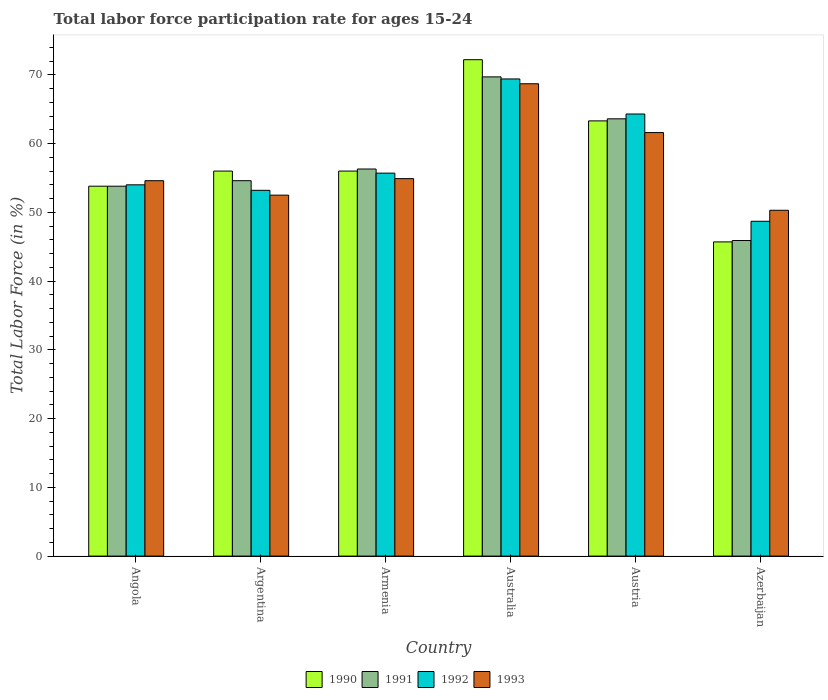How many different coloured bars are there?
Give a very brief answer. 4. How many groups of bars are there?
Your answer should be compact. 6. Are the number of bars per tick equal to the number of legend labels?
Your answer should be very brief. Yes. What is the label of the 2nd group of bars from the left?
Offer a terse response. Argentina. What is the labor force participation rate in 1992 in Argentina?
Make the answer very short. 53.2. Across all countries, what is the maximum labor force participation rate in 1992?
Ensure brevity in your answer.  69.4. Across all countries, what is the minimum labor force participation rate in 1992?
Your answer should be compact. 48.7. In which country was the labor force participation rate in 1992 maximum?
Offer a terse response. Australia. In which country was the labor force participation rate in 1990 minimum?
Offer a terse response. Azerbaijan. What is the total labor force participation rate in 1991 in the graph?
Your answer should be very brief. 343.9. What is the difference between the labor force participation rate in 1991 in Angola and that in Australia?
Keep it short and to the point. -15.9. What is the difference between the labor force participation rate in 1993 in Austria and the labor force participation rate in 1990 in Australia?
Keep it short and to the point. -10.6. What is the average labor force participation rate in 1993 per country?
Provide a short and direct response. 57.1. What is the difference between the labor force participation rate of/in 1992 and labor force participation rate of/in 1993 in Argentina?
Offer a terse response. 0.7. What is the ratio of the labor force participation rate in 1992 in Argentina to that in Austria?
Make the answer very short. 0.83. Is the labor force participation rate in 1992 in Australia less than that in Azerbaijan?
Make the answer very short. No. Is the difference between the labor force participation rate in 1992 in Argentina and Austria greater than the difference between the labor force participation rate in 1993 in Argentina and Austria?
Provide a succinct answer. No. What is the difference between the highest and the second highest labor force participation rate in 1990?
Give a very brief answer. 16.2. What is the difference between the highest and the lowest labor force participation rate in 1990?
Offer a very short reply. 26.5. In how many countries, is the labor force participation rate in 1990 greater than the average labor force participation rate in 1990 taken over all countries?
Provide a short and direct response. 2. Is the sum of the labor force participation rate in 1993 in Argentina and Armenia greater than the maximum labor force participation rate in 1991 across all countries?
Provide a succinct answer. Yes. What does the 4th bar from the right in Austria represents?
Offer a terse response. 1990. Is it the case that in every country, the sum of the labor force participation rate in 1992 and labor force participation rate in 1990 is greater than the labor force participation rate in 1991?
Provide a succinct answer. Yes. How many bars are there?
Your answer should be compact. 24. Are all the bars in the graph horizontal?
Your response must be concise. No. What is the difference between two consecutive major ticks on the Y-axis?
Provide a short and direct response. 10. Are the values on the major ticks of Y-axis written in scientific E-notation?
Offer a terse response. No. Does the graph contain any zero values?
Your response must be concise. No. Does the graph contain grids?
Offer a very short reply. No. Where does the legend appear in the graph?
Make the answer very short. Bottom center. How many legend labels are there?
Your answer should be compact. 4. How are the legend labels stacked?
Your answer should be compact. Horizontal. What is the title of the graph?
Ensure brevity in your answer.  Total labor force participation rate for ages 15-24. Does "1978" appear as one of the legend labels in the graph?
Make the answer very short. No. What is the Total Labor Force (in %) in 1990 in Angola?
Provide a short and direct response. 53.8. What is the Total Labor Force (in %) of 1991 in Angola?
Offer a terse response. 53.8. What is the Total Labor Force (in %) of 1992 in Angola?
Offer a terse response. 54. What is the Total Labor Force (in %) of 1993 in Angola?
Keep it short and to the point. 54.6. What is the Total Labor Force (in %) in 1990 in Argentina?
Make the answer very short. 56. What is the Total Labor Force (in %) of 1991 in Argentina?
Offer a terse response. 54.6. What is the Total Labor Force (in %) in 1992 in Argentina?
Offer a very short reply. 53.2. What is the Total Labor Force (in %) in 1993 in Argentina?
Provide a succinct answer. 52.5. What is the Total Labor Force (in %) of 1991 in Armenia?
Make the answer very short. 56.3. What is the Total Labor Force (in %) of 1992 in Armenia?
Give a very brief answer. 55.7. What is the Total Labor Force (in %) in 1993 in Armenia?
Your answer should be very brief. 54.9. What is the Total Labor Force (in %) in 1990 in Australia?
Make the answer very short. 72.2. What is the Total Labor Force (in %) of 1991 in Australia?
Offer a terse response. 69.7. What is the Total Labor Force (in %) in 1992 in Australia?
Provide a succinct answer. 69.4. What is the Total Labor Force (in %) of 1993 in Australia?
Keep it short and to the point. 68.7. What is the Total Labor Force (in %) in 1990 in Austria?
Provide a succinct answer. 63.3. What is the Total Labor Force (in %) in 1991 in Austria?
Provide a succinct answer. 63.6. What is the Total Labor Force (in %) of 1992 in Austria?
Give a very brief answer. 64.3. What is the Total Labor Force (in %) of 1993 in Austria?
Offer a very short reply. 61.6. What is the Total Labor Force (in %) of 1990 in Azerbaijan?
Provide a short and direct response. 45.7. What is the Total Labor Force (in %) in 1991 in Azerbaijan?
Keep it short and to the point. 45.9. What is the Total Labor Force (in %) of 1992 in Azerbaijan?
Offer a terse response. 48.7. What is the Total Labor Force (in %) in 1993 in Azerbaijan?
Give a very brief answer. 50.3. Across all countries, what is the maximum Total Labor Force (in %) in 1990?
Provide a succinct answer. 72.2. Across all countries, what is the maximum Total Labor Force (in %) of 1991?
Offer a terse response. 69.7. Across all countries, what is the maximum Total Labor Force (in %) of 1992?
Your answer should be very brief. 69.4. Across all countries, what is the maximum Total Labor Force (in %) in 1993?
Make the answer very short. 68.7. Across all countries, what is the minimum Total Labor Force (in %) of 1990?
Provide a short and direct response. 45.7. Across all countries, what is the minimum Total Labor Force (in %) in 1991?
Provide a succinct answer. 45.9. Across all countries, what is the minimum Total Labor Force (in %) in 1992?
Keep it short and to the point. 48.7. Across all countries, what is the minimum Total Labor Force (in %) in 1993?
Offer a terse response. 50.3. What is the total Total Labor Force (in %) of 1990 in the graph?
Offer a terse response. 347. What is the total Total Labor Force (in %) of 1991 in the graph?
Offer a very short reply. 343.9. What is the total Total Labor Force (in %) in 1992 in the graph?
Your answer should be compact. 345.3. What is the total Total Labor Force (in %) in 1993 in the graph?
Give a very brief answer. 342.6. What is the difference between the Total Labor Force (in %) in 1990 in Angola and that in Argentina?
Provide a short and direct response. -2.2. What is the difference between the Total Labor Force (in %) of 1991 in Angola and that in Argentina?
Your answer should be compact. -0.8. What is the difference between the Total Labor Force (in %) of 1992 in Angola and that in Argentina?
Your answer should be compact. 0.8. What is the difference between the Total Labor Force (in %) of 1990 in Angola and that in Australia?
Keep it short and to the point. -18.4. What is the difference between the Total Labor Force (in %) of 1991 in Angola and that in Australia?
Provide a succinct answer. -15.9. What is the difference between the Total Labor Force (in %) in 1992 in Angola and that in Australia?
Keep it short and to the point. -15.4. What is the difference between the Total Labor Force (in %) in 1993 in Angola and that in Australia?
Your answer should be very brief. -14.1. What is the difference between the Total Labor Force (in %) in 1991 in Angola and that in Austria?
Ensure brevity in your answer.  -9.8. What is the difference between the Total Labor Force (in %) of 1990 in Angola and that in Azerbaijan?
Keep it short and to the point. 8.1. What is the difference between the Total Labor Force (in %) of 1992 in Angola and that in Azerbaijan?
Keep it short and to the point. 5.3. What is the difference between the Total Labor Force (in %) in 1993 in Angola and that in Azerbaijan?
Your response must be concise. 4.3. What is the difference between the Total Labor Force (in %) in 1991 in Argentina and that in Armenia?
Your answer should be compact. -1.7. What is the difference between the Total Labor Force (in %) in 1990 in Argentina and that in Australia?
Offer a very short reply. -16.2. What is the difference between the Total Labor Force (in %) of 1991 in Argentina and that in Australia?
Give a very brief answer. -15.1. What is the difference between the Total Labor Force (in %) of 1992 in Argentina and that in Australia?
Keep it short and to the point. -16.2. What is the difference between the Total Labor Force (in %) of 1993 in Argentina and that in Australia?
Ensure brevity in your answer.  -16.2. What is the difference between the Total Labor Force (in %) of 1990 in Argentina and that in Austria?
Your answer should be compact. -7.3. What is the difference between the Total Labor Force (in %) of 1992 in Argentina and that in Austria?
Ensure brevity in your answer.  -11.1. What is the difference between the Total Labor Force (in %) in 1991 in Argentina and that in Azerbaijan?
Keep it short and to the point. 8.7. What is the difference between the Total Labor Force (in %) in 1993 in Argentina and that in Azerbaijan?
Offer a very short reply. 2.2. What is the difference between the Total Labor Force (in %) in 1990 in Armenia and that in Australia?
Give a very brief answer. -16.2. What is the difference between the Total Labor Force (in %) in 1991 in Armenia and that in Australia?
Your response must be concise. -13.4. What is the difference between the Total Labor Force (in %) of 1992 in Armenia and that in Australia?
Provide a short and direct response. -13.7. What is the difference between the Total Labor Force (in %) of 1993 in Armenia and that in Australia?
Offer a very short reply. -13.8. What is the difference between the Total Labor Force (in %) of 1990 in Armenia and that in Austria?
Keep it short and to the point. -7.3. What is the difference between the Total Labor Force (in %) of 1990 in Armenia and that in Azerbaijan?
Offer a terse response. 10.3. What is the difference between the Total Labor Force (in %) of 1992 in Armenia and that in Azerbaijan?
Give a very brief answer. 7. What is the difference between the Total Labor Force (in %) in 1993 in Armenia and that in Azerbaijan?
Provide a short and direct response. 4.6. What is the difference between the Total Labor Force (in %) of 1991 in Australia and that in Austria?
Keep it short and to the point. 6.1. What is the difference between the Total Labor Force (in %) of 1991 in Australia and that in Azerbaijan?
Offer a terse response. 23.8. What is the difference between the Total Labor Force (in %) of 1992 in Australia and that in Azerbaijan?
Your response must be concise. 20.7. What is the difference between the Total Labor Force (in %) in 1993 in Australia and that in Azerbaijan?
Keep it short and to the point. 18.4. What is the difference between the Total Labor Force (in %) in 1990 in Austria and that in Azerbaijan?
Offer a terse response. 17.6. What is the difference between the Total Labor Force (in %) in 1991 in Austria and that in Azerbaijan?
Keep it short and to the point. 17.7. What is the difference between the Total Labor Force (in %) of 1992 in Austria and that in Azerbaijan?
Offer a terse response. 15.6. What is the difference between the Total Labor Force (in %) of 1991 in Angola and the Total Labor Force (in %) of 1993 in Armenia?
Keep it short and to the point. -1.1. What is the difference between the Total Labor Force (in %) of 1992 in Angola and the Total Labor Force (in %) of 1993 in Armenia?
Your answer should be very brief. -0.9. What is the difference between the Total Labor Force (in %) of 1990 in Angola and the Total Labor Force (in %) of 1991 in Australia?
Keep it short and to the point. -15.9. What is the difference between the Total Labor Force (in %) in 1990 in Angola and the Total Labor Force (in %) in 1992 in Australia?
Your answer should be compact. -15.6. What is the difference between the Total Labor Force (in %) in 1990 in Angola and the Total Labor Force (in %) in 1993 in Australia?
Ensure brevity in your answer.  -14.9. What is the difference between the Total Labor Force (in %) of 1991 in Angola and the Total Labor Force (in %) of 1992 in Australia?
Make the answer very short. -15.6. What is the difference between the Total Labor Force (in %) in 1991 in Angola and the Total Labor Force (in %) in 1993 in Australia?
Provide a succinct answer. -14.9. What is the difference between the Total Labor Force (in %) in 1992 in Angola and the Total Labor Force (in %) in 1993 in Australia?
Make the answer very short. -14.7. What is the difference between the Total Labor Force (in %) of 1990 in Angola and the Total Labor Force (in %) of 1991 in Austria?
Your response must be concise. -9.8. What is the difference between the Total Labor Force (in %) of 1990 in Angola and the Total Labor Force (in %) of 1992 in Austria?
Provide a succinct answer. -10.5. What is the difference between the Total Labor Force (in %) in 1990 in Angola and the Total Labor Force (in %) in 1993 in Austria?
Ensure brevity in your answer.  -7.8. What is the difference between the Total Labor Force (in %) of 1990 in Angola and the Total Labor Force (in %) of 1992 in Azerbaijan?
Your answer should be compact. 5.1. What is the difference between the Total Labor Force (in %) of 1990 in Angola and the Total Labor Force (in %) of 1993 in Azerbaijan?
Offer a terse response. 3.5. What is the difference between the Total Labor Force (in %) in 1991 in Angola and the Total Labor Force (in %) in 1992 in Azerbaijan?
Ensure brevity in your answer.  5.1. What is the difference between the Total Labor Force (in %) of 1992 in Angola and the Total Labor Force (in %) of 1993 in Azerbaijan?
Give a very brief answer. 3.7. What is the difference between the Total Labor Force (in %) in 1990 in Argentina and the Total Labor Force (in %) in 1991 in Armenia?
Make the answer very short. -0.3. What is the difference between the Total Labor Force (in %) of 1990 in Argentina and the Total Labor Force (in %) of 1993 in Armenia?
Ensure brevity in your answer.  1.1. What is the difference between the Total Labor Force (in %) of 1991 in Argentina and the Total Labor Force (in %) of 1992 in Armenia?
Your response must be concise. -1.1. What is the difference between the Total Labor Force (in %) of 1992 in Argentina and the Total Labor Force (in %) of 1993 in Armenia?
Give a very brief answer. -1.7. What is the difference between the Total Labor Force (in %) in 1990 in Argentina and the Total Labor Force (in %) in 1991 in Australia?
Make the answer very short. -13.7. What is the difference between the Total Labor Force (in %) in 1991 in Argentina and the Total Labor Force (in %) in 1992 in Australia?
Provide a succinct answer. -14.8. What is the difference between the Total Labor Force (in %) in 1991 in Argentina and the Total Labor Force (in %) in 1993 in Australia?
Make the answer very short. -14.1. What is the difference between the Total Labor Force (in %) of 1992 in Argentina and the Total Labor Force (in %) of 1993 in Australia?
Offer a terse response. -15.5. What is the difference between the Total Labor Force (in %) of 1990 in Argentina and the Total Labor Force (in %) of 1991 in Austria?
Provide a short and direct response. -7.6. What is the difference between the Total Labor Force (in %) in 1991 in Argentina and the Total Labor Force (in %) in 1992 in Austria?
Offer a terse response. -9.7. What is the difference between the Total Labor Force (in %) in 1992 in Argentina and the Total Labor Force (in %) in 1993 in Austria?
Keep it short and to the point. -8.4. What is the difference between the Total Labor Force (in %) in 1990 in Argentina and the Total Labor Force (in %) in 1991 in Azerbaijan?
Keep it short and to the point. 10.1. What is the difference between the Total Labor Force (in %) of 1991 in Argentina and the Total Labor Force (in %) of 1992 in Azerbaijan?
Provide a short and direct response. 5.9. What is the difference between the Total Labor Force (in %) of 1990 in Armenia and the Total Labor Force (in %) of 1991 in Australia?
Ensure brevity in your answer.  -13.7. What is the difference between the Total Labor Force (in %) in 1990 in Armenia and the Total Labor Force (in %) in 1992 in Australia?
Give a very brief answer. -13.4. What is the difference between the Total Labor Force (in %) of 1990 in Armenia and the Total Labor Force (in %) of 1993 in Australia?
Provide a short and direct response. -12.7. What is the difference between the Total Labor Force (in %) of 1991 in Armenia and the Total Labor Force (in %) of 1992 in Australia?
Keep it short and to the point. -13.1. What is the difference between the Total Labor Force (in %) in 1992 in Armenia and the Total Labor Force (in %) in 1993 in Australia?
Offer a very short reply. -13. What is the difference between the Total Labor Force (in %) of 1990 in Armenia and the Total Labor Force (in %) of 1991 in Austria?
Make the answer very short. -7.6. What is the difference between the Total Labor Force (in %) in 1990 in Armenia and the Total Labor Force (in %) in 1992 in Austria?
Your answer should be very brief. -8.3. What is the difference between the Total Labor Force (in %) of 1990 in Armenia and the Total Labor Force (in %) of 1993 in Austria?
Give a very brief answer. -5.6. What is the difference between the Total Labor Force (in %) of 1991 in Armenia and the Total Labor Force (in %) of 1992 in Austria?
Offer a very short reply. -8. What is the difference between the Total Labor Force (in %) of 1991 in Armenia and the Total Labor Force (in %) of 1993 in Austria?
Offer a terse response. -5.3. What is the difference between the Total Labor Force (in %) in 1990 in Armenia and the Total Labor Force (in %) in 1991 in Azerbaijan?
Ensure brevity in your answer.  10.1. What is the difference between the Total Labor Force (in %) of 1991 in Armenia and the Total Labor Force (in %) of 1992 in Azerbaijan?
Make the answer very short. 7.6. What is the difference between the Total Labor Force (in %) in 1990 in Australia and the Total Labor Force (in %) in 1991 in Austria?
Your answer should be very brief. 8.6. What is the difference between the Total Labor Force (in %) of 1991 in Australia and the Total Labor Force (in %) of 1993 in Austria?
Make the answer very short. 8.1. What is the difference between the Total Labor Force (in %) in 1990 in Australia and the Total Labor Force (in %) in 1991 in Azerbaijan?
Provide a short and direct response. 26.3. What is the difference between the Total Labor Force (in %) in 1990 in Australia and the Total Labor Force (in %) in 1992 in Azerbaijan?
Your answer should be very brief. 23.5. What is the difference between the Total Labor Force (in %) in 1990 in Australia and the Total Labor Force (in %) in 1993 in Azerbaijan?
Offer a terse response. 21.9. What is the difference between the Total Labor Force (in %) in 1991 in Australia and the Total Labor Force (in %) in 1992 in Azerbaijan?
Give a very brief answer. 21. What is the difference between the Total Labor Force (in %) of 1990 in Austria and the Total Labor Force (in %) of 1991 in Azerbaijan?
Ensure brevity in your answer.  17.4. What is the difference between the Total Labor Force (in %) of 1990 in Austria and the Total Labor Force (in %) of 1992 in Azerbaijan?
Keep it short and to the point. 14.6. What is the difference between the Total Labor Force (in %) in 1990 in Austria and the Total Labor Force (in %) in 1993 in Azerbaijan?
Offer a very short reply. 13. What is the difference between the Total Labor Force (in %) in 1991 in Austria and the Total Labor Force (in %) in 1993 in Azerbaijan?
Ensure brevity in your answer.  13.3. What is the average Total Labor Force (in %) of 1990 per country?
Make the answer very short. 57.83. What is the average Total Labor Force (in %) of 1991 per country?
Provide a succinct answer. 57.32. What is the average Total Labor Force (in %) in 1992 per country?
Ensure brevity in your answer.  57.55. What is the average Total Labor Force (in %) of 1993 per country?
Provide a succinct answer. 57.1. What is the difference between the Total Labor Force (in %) in 1990 and Total Labor Force (in %) in 1991 in Angola?
Give a very brief answer. 0. What is the difference between the Total Labor Force (in %) in 1990 and Total Labor Force (in %) in 1993 in Angola?
Provide a short and direct response. -0.8. What is the difference between the Total Labor Force (in %) in 1991 and Total Labor Force (in %) in 1992 in Angola?
Give a very brief answer. -0.2. What is the difference between the Total Labor Force (in %) of 1990 and Total Labor Force (in %) of 1993 in Argentina?
Your answer should be very brief. 3.5. What is the difference between the Total Labor Force (in %) in 1991 and Total Labor Force (in %) in 1992 in Argentina?
Ensure brevity in your answer.  1.4. What is the difference between the Total Labor Force (in %) in 1991 and Total Labor Force (in %) in 1993 in Argentina?
Your response must be concise. 2.1. What is the difference between the Total Labor Force (in %) of 1990 and Total Labor Force (in %) of 1992 in Armenia?
Keep it short and to the point. 0.3. What is the difference between the Total Labor Force (in %) in 1991 and Total Labor Force (in %) in 1993 in Armenia?
Offer a terse response. 1.4. What is the difference between the Total Labor Force (in %) of 1992 and Total Labor Force (in %) of 1993 in Armenia?
Offer a terse response. 0.8. What is the difference between the Total Labor Force (in %) in 1990 and Total Labor Force (in %) in 1991 in Australia?
Your answer should be compact. 2.5. What is the difference between the Total Labor Force (in %) of 1991 and Total Labor Force (in %) of 1992 in Australia?
Provide a short and direct response. 0.3. What is the difference between the Total Labor Force (in %) of 1990 and Total Labor Force (in %) of 1991 in Austria?
Offer a terse response. -0.3. What is the difference between the Total Labor Force (in %) in 1991 and Total Labor Force (in %) in 1992 in Austria?
Provide a short and direct response. -0.7. What is the difference between the Total Labor Force (in %) in 1991 and Total Labor Force (in %) in 1993 in Austria?
Provide a succinct answer. 2. What is the difference between the Total Labor Force (in %) of 1990 and Total Labor Force (in %) of 1991 in Azerbaijan?
Make the answer very short. -0.2. What is the difference between the Total Labor Force (in %) in 1990 and Total Labor Force (in %) in 1993 in Azerbaijan?
Make the answer very short. -4.6. What is the difference between the Total Labor Force (in %) of 1991 and Total Labor Force (in %) of 1993 in Azerbaijan?
Your response must be concise. -4.4. What is the difference between the Total Labor Force (in %) in 1992 and Total Labor Force (in %) in 1993 in Azerbaijan?
Give a very brief answer. -1.6. What is the ratio of the Total Labor Force (in %) in 1990 in Angola to that in Argentina?
Your answer should be compact. 0.96. What is the ratio of the Total Labor Force (in %) of 1990 in Angola to that in Armenia?
Your answer should be very brief. 0.96. What is the ratio of the Total Labor Force (in %) of 1991 in Angola to that in Armenia?
Keep it short and to the point. 0.96. What is the ratio of the Total Labor Force (in %) in 1992 in Angola to that in Armenia?
Your response must be concise. 0.97. What is the ratio of the Total Labor Force (in %) in 1990 in Angola to that in Australia?
Ensure brevity in your answer.  0.75. What is the ratio of the Total Labor Force (in %) in 1991 in Angola to that in Australia?
Provide a succinct answer. 0.77. What is the ratio of the Total Labor Force (in %) in 1992 in Angola to that in Australia?
Provide a short and direct response. 0.78. What is the ratio of the Total Labor Force (in %) in 1993 in Angola to that in Australia?
Give a very brief answer. 0.79. What is the ratio of the Total Labor Force (in %) in 1990 in Angola to that in Austria?
Provide a succinct answer. 0.85. What is the ratio of the Total Labor Force (in %) of 1991 in Angola to that in Austria?
Your answer should be very brief. 0.85. What is the ratio of the Total Labor Force (in %) of 1992 in Angola to that in Austria?
Offer a terse response. 0.84. What is the ratio of the Total Labor Force (in %) of 1993 in Angola to that in Austria?
Your answer should be very brief. 0.89. What is the ratio of the Total Labor Force (in %) of 1990 in Angola to that in Azerbaijan?
Your answer should be very brief. 1.18. What is the ratio of the Total Labor Force (in %) of 1991 in Angola to that in Azerbaijan?
Make the answer very short. 1.17. What is the ratio of the Total Labor Force (in %) of 1992 in Angola to that in Azerbaijan?
Offer a very short reply. 1.11. What is the ratio of the Total Labor Force (in %) in 1993 in Angola to that in Azerbaijan?
Your answer should be very brief. 1.09. What is the ratio of the Total Labor Force (in %) of 1991 in Argentina to that in Armenia?
Your response must be concise. 0.97. What is the ratio of the Total Labor Force (in %) of 1992 in Argentina to that in Armenia?
Give a very brief answer. 0.96. What is the ratio of the Total Labor Force (in %) in 1993 in Argentina to that in Armenia?
Ensure brevity in your answer.  0.96. What is the ratio of the Total Labor Force (in %) in 1990 in Argentina to that in Australia?
Provide a succinct answer. 0.78. What is the ratio of the Total Labor Force (in %) of 1991 in Argentina to that in Australia?
Your answer should be compact. 0.78. What is the ratio of the Total Labor Force (in %) in 1992 in Argentina to that in Australia?
Make the answer very short. 0.77. What is the ratio of the Total Labor Force (in %) of 1993 in Argentina to that in Australia?
Keep it short and to the point. 0.76. What is the ratio of the Total Labor Force (in %) of 1990 in Argentina to that in Austria?
Make the answer very short. 0.88. What is the ratio of the Total Labor Force (in %) in 1991 in Argentina to that in Austria?
Give a very brief answer. 0.86. What is the ratio of the Total Labor Force (in %) in 1992 in Argentina to that in Austria?
Make the answer very short. 0.83. What is the ratio of the Total Labor Force (in %) of 1993 in Argentina to that in Austria?
Your response must be concise. 0.85. What is the ratio of the Total Labor Force (in %) of 1990 in Argentina to that in Azerbaijan?
Keep it short and to the point. 1.23. What is the ratio of the Total Labor Force (in %) in 1991 in Argentina to that in Azerbaijan?
Offer a terse response. 1.19. What is the ratio of the Total Labor Force (in %) of 1992 in Argentina to that in Azerbaijan?
Offer a terse response. 1.09. What is the ratio of the Total Labor Force (in %) of 1993 in Argentina to that in Azerbaijan?
Your response must be concise. 1.04. What is the ratio of the Total Labor Force (in %) in 1990 in Armenia to that in Australia?
Provide a short and direct response. 0.78. What is the ratio of the Total Labor Force (in %) of 1991 in Armenia to that in Australia?
Keep it short and to the point. 0.81. What is the ratio of the Total Labor Force (in %) of 1992 in Armenia to that in Australia?
Give a very brief answer. 0.8. What is the ratio of the Total Labor Force (in %) of 1993 in Armenia to that in Australia?
Keep it short and to the point. 0.8. What is the ratio of the Total Labor Force (in %) of 1990 in Armenia to that in Austria?
Offer a terse response. 0.88. What is the ratio of the Total Labor Force (in %) in 1991 in Armenia to that in Austria?
Your response must be concise. 0.89. What is the ratio of the Total Labor Force (in %) in 1992 in Armenia to that in Austria?
Offer a very short reply. 0.87. What is the ratio of the Total Labor Force (in %) in 1993 in Armenia to that in Austria?
Your response must be concise. 0.89. What is the ratio of the Total Labor Force (in %) of 1990 in Armenia to that in Azerbaijan?
Give a very brief answer. 1.23. What is the ratio of the Total Labor Force (in %) of 1991 in Armenia to that in Azerbaijan?
Your answer should be very brief. 1.23. What is the ratio of the Total Labor Force (in %) in 1992 in Armenia to that in Azerbaijan?
Provide a short and direct response. 1.14. What is the ratio of the Total Labor Force (in %) of 1993 in Armenia to that in Azerbaijan?
Offer a very short reply. 1.09. What is the ratio of the Total Labor Force (in %) in 1990 in Australia to that in Austria?
Give a very brief answer. 1.14. What is the ratio of the Total Labor Force (in %) in 1991 in Australia to that in Austria?
Give a very brief answer. 1.1. What is the ratio of the Total Labor Force (in %) in 1992 in Australia to that in Austria?
Your response must be concise. 1.08. What is the ratio of the Total Labor Force (in %) in 1993 in Australia to that in Austria?
Ensure brevity in your answer.  1.12. What is the ratio of the Total Labor Force (in %) in 1990 in Australia to that in Azerbaijan?
Your answer should be compact. 1.58. What is the ratio of the Total Labor Force (in %) of 1991 in Australia to that in Azerbaijan?
Offer a very short reply. 1.52. What is the ratio of the Total Labor Force (in %) of 1992 in Australia to that in Azerbaijan?
Provide a succinct answer. 1.43. What is the ratio of the Total Labor Force (in %) in 1993 in Australia to that in Azerbaijan?
Your response must be concise. 1.37. What is the ratio of the Total Labor Force (in %) in 1990 in Austria to that in Azerbaijan?
Ensure brevity in your answer.  1.39. What is the ratio of the Total Labor Force (in %) in 1991 in Austria to that in Azerbaijan?
Provide a short and direct response. 1.39. What is the ratio of the Total Labor Force (in %) in 1992 in Austria to that in Azerbaijan?
Your answer should be compact. 1.32. What is the ratio of the Total Labor Force (in %) of 1993 in Austria to that in Azerbaijan?
Give a very brief answer. 1.22. What is the difference between the highest and the second highest Total Labor Force (in %) of 1990?
Give a very brief answer. 8.9. What is the difference between the highest and the lowest Total Labor Force (in %) of 1990?
Provide a short and direct response. 26.5. What is the difference between the highest and the lowest Total Labor Force (in %) in 1991?
Provide a short and direct response. 23.8. What is the difference between the highest and the lowest Total Labor Force (in %) in 1992?
Your response must be concise. 20.7. What is the difference between the highest and the lowest Total Labor Force (in %) of 1993?
Offer a terse response. 18.4. 